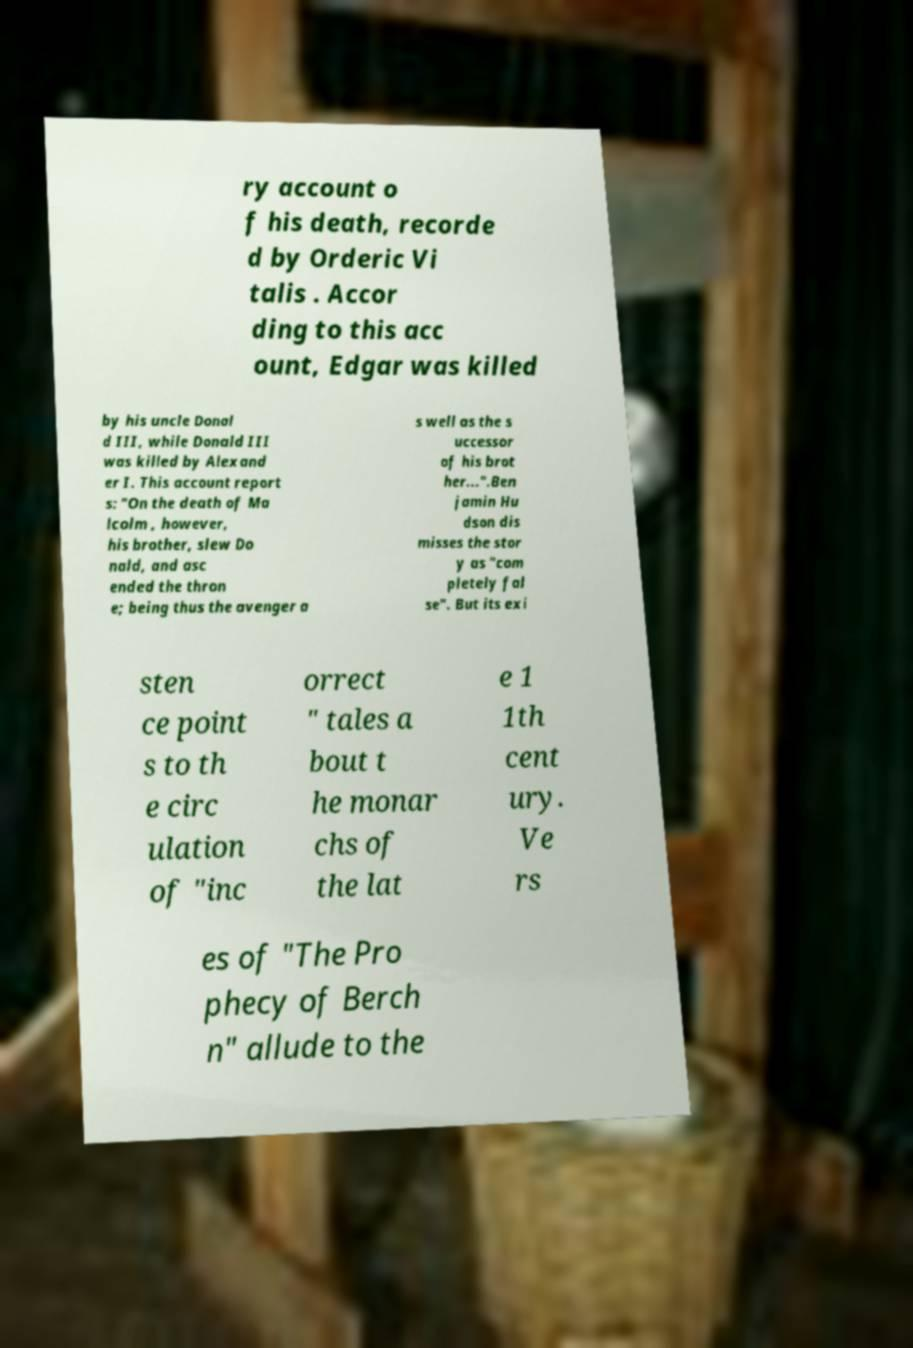What messages or text are displayed in this image? I need them in a readable, typed format. ry account o f his death, recorde d by Orderic Vi talis . Accor ding to this acc ount, Edgar was killed by his uncle Donal d III, while Donald III was killed by Alexand er I. This account report s: "On the death of Ma lcolm , however, his brother, slew Do nald, and asc ended the thron e; being thus the avenger a s well as the s uccessor of his brot her...".Ben jamin Hu dson dis misses the stor y as "com pletely fal se". But its exi sten ce point s to th e circ ulation of "inc orrect " tales a bout t he monar chs of the lat e 1 1th cent ury. Ve rs es of "The Pro phecy of Berch n" allude to the 